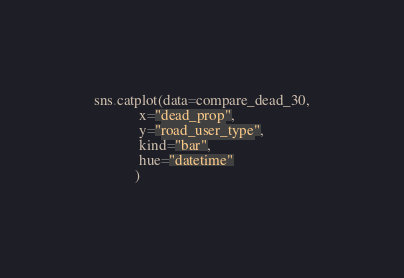Convert code to text. <code><loc_0><loc_0><loc_500><loc_500><_Python_>sns.catplot(data=compare_dead_30,
            x="dead_prop",
            y="road_user_type",
            kind="bar",
            hue="datetime"
           )</code> 